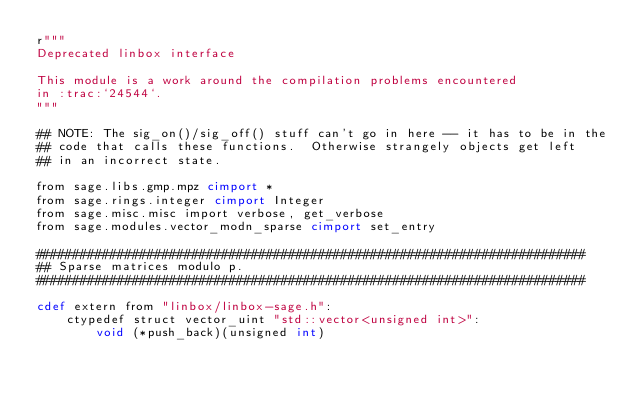<code> <loc_0><loc_0><loc_500><loc_500><_Cython_>r"""
Deprecated linbox interface

This module is a work around the compilation problems encountered
in :trac:`24544`.
"""

## NOTE: The sig_on()/sig_off() stuff can't go in here -- it has to be in the
## code that calls these functions.  Otherwise strangely objects get left
## in an incorrect state.

from sage.libs.gmp.mpz cimport *
from sage.rings.integer cimport Integer
from sage.misc.misc import verbose, get_verbose
from sage.modules.vector_modn_sparse cimport set_entry

##########################################################################
## Sparse matrices modulo p.
##########################################################################

cdef extern from "linbox/linbox-sage.h":
    ctypedef struct vector_uint "std::vector<unsigned int>":
        void (*push_back)(unsigned int)</code> 